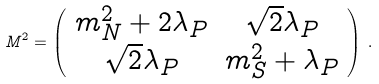<formula> <loc_0><loc_0><loc_500><loc_500>M ^ { 2 } = \left ( \begin{array} { c c } m ^ { 2 } _ { N } + 2 \lambda _ { P } & \sqrt { 2 } \lambda _ { P } \\ \sqrt { 2 } \lambda _ { P } & m ^ { 2 } _ { S } + \lambda _ { P } \end{array} \right ) \, .</formula> 